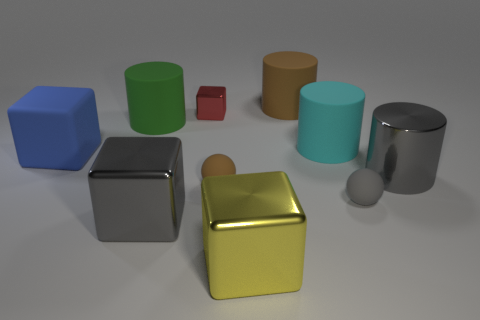There is a rubber cube that is the same size as the green thing; what is its color?
Give a very brief answer. Blue. There is a large metal object that is in front of the big gray thing to the left of the big gray thing to the right of the tiny brown thing; what color is it?
Your response must be concise. Yellow. What number of large metal cylinders are in front of the big yellow object on the left side of the gray metal thing to the right of the small red thing?
Your answer should be very brief. 0. Is there any other thing of the same color as the small shiny block?
Your answer should be very brief. No. There is a rubber thing that is left of the green thing; is it the same size as the big green rubber cylinder?
Your answer should be very brief. Yes. How many big gray cylinders are in front of the large cylinder that is left of the brown rubber cylinder?
Provide a succinct answer. 1. Are there any cyan cylinders that are on the right side of the big metallic thing that is behind the matte sphere that is on the left side of the big brown object?
Provide a succinct answer. No. What material is the gray object that is the same shape as the cyan object?
Give a very brief answer. Metal. Is there anything else that is the same material as the gray cylinder?
Offer a terse response. Yes. Are the red thing and the large gray object in front of the tiny brown sphere made of the same material?
Provide a short and direct response. Yes. 